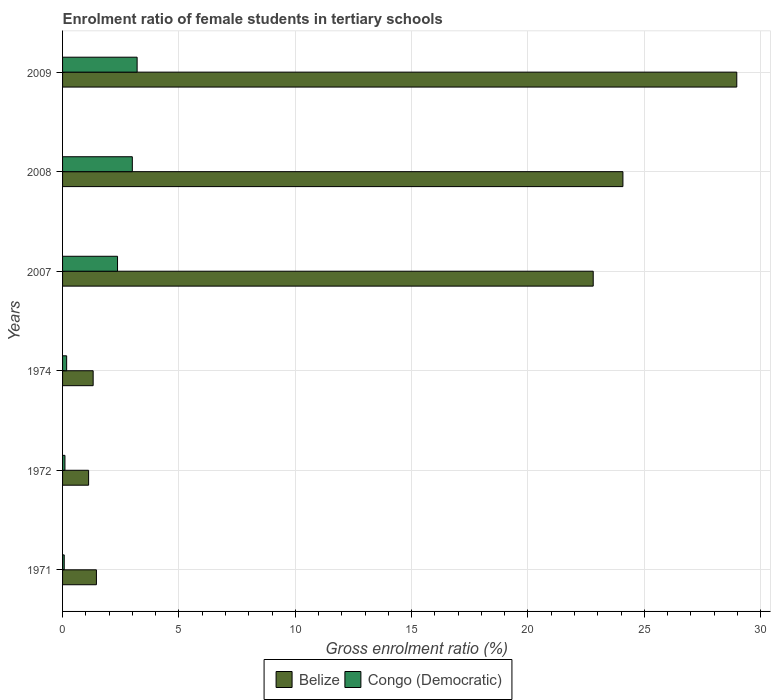Are the number of bars per tick equal to the number of legend labels?
Give a very brief answer. Yes. How many bars are there on the 1st tick from the bottom?
Your response must be concise. 2. What is the enrolment ratio of female students in tertiary schools in Belize in 2009?
Give a very brief answer. 28.97. Across all years, what is the maximum enrolment ratio of female students in tertiary schools in Congo (Democratic)?
Provide a succinct answer. 3.2. Across all years, what is the minimum enrolment ratio of female students in tertiary schools in Belize?
Provide a succinct answer. 1.12. In which year was the enrolment ratio of female students in tertiary schools in Congo (Democratic) maximum?
Your answer should be very brief. 2009. What is the total enrolment ratio of female students in tertiary schools in Congo (Democratic) in the graph?
Make the answer very short. 8.91. What is the difference between the enrolment ratio of female students in tertiary schools in Belize in 1972 and that in 1974?
Provide a succinct answer. -0.2. What is the difference between the enrolment ratio of female students in tertiary schools in Belize in 2007 and the enrolment ratio of female students in tertiary schools in Congo (Democratic) in 1972?
Provide a short and direct response. 22.7. What is the average enrolment ratio of female students in tertiary schools in Belize per year?
Provide a short and direct response. 13.29. In the year 1971, what is the difference between the enrolment ratio of female students in tertiary schools in Belize and enrolment ratio of female students in tertiary schools in Congo (Democratic)?
Ensure brevity in your answer.  1.38. In how many years, is the enrolment ratio of female students in tertiary schools in Belize greater than 29 %?
Keep it short and to the point. 0. What is the ratio of the enrolment ratio of female students in tertiary schools in Congo (Democratic) in 1972 to that in 2009?
Your response must be concise. 0.03. Is the enrolment ratio of female students in tertiary schools in Belize in 1971 less than that in 2008?
Keep it short and to the point. Yes. Is the difference between the enrolment ratio of female students in tertiary schools in Belize in 1971 and 1974 greater than the difference between the enrolment ratio of female students in tertiary schools in Congo (Democratic) in 1971 and 1974?
Offer a terse response. Yes. What is the difference between the highest and the second highest enrolment ratio of female students in tertiary schools in Belize?
Offer a terse response. 4.89. What is the difference between the highest and the lowest enrolment ratio of female students in tertiary schools in Belize?
Provide a short and direct response. 27.85. What does the 2nd bar from the top in 2007 represents?
Your answer should be very brief. Belize. What does the 2nd bar from the bottom in 1971 represents?
Your response must be concise. Congo (Democratic). How many bars are there?
Your answer should be very brief. 12. What is the difference between two consecutive major ticks on the X-axis?
Your response must be concise. 5. Does the graph contain any zero values?
Ensure brevity in your answer.  No. Does the graph contain grids?
Your response must be concise. Yes. How many legend labels are there?
Your answer should be compact. 2. What is the title of the graph?
Make the answer very short. Enrolment ratio of female students in tertiary schools. Does "Euro area" appear as one of the legend labels in the graph?
Your answer should be very brief. No. What is the label or title of the X-axis?
Offer a terse response. Gross enrolment ratio (%). What is the Gross enrolment ratio (%) of Belize in 1971?
Keep it short and to the point. 1.46. What is the Gross enrolment ratio (%) in Congo (Democratic) in 1971?
Give a very brief answer. 0.07. What is the Gross enrolment ratio (%) of Belize in 1972?
Keep it short and to the point. 1.12. What is the Gross enrolment ratio (%) in Congo (Democratic) in 1972?
Your response must be concise. 0.1. What is the Gross enrolment ratio (%) in Belize in 1974?
Your response must be concise. 1.31. What is the Gross enrolment ratio (%) in Congo (Democratic) in 1974?
Make the answer very short. 0.18. What is the Gross enrolment ratio (%) in Belize in 2007?
Offer a terse response. 22.8. What is the Gross enrolment ratio (%) of Congo (Democratic) in 2007?
Provide a succinct answer. 2.36. What is the Gross enrolment ratio (%) of Belize in 2008?
Give a very brief answer. 24.08. What is the Gross enrolment ratio (%) of Congo (Democratic) in 2008?
Make the answer very short. 3. What is the Gross enrolment ratio (%) in Belize in 2009?
Keep it short and to the point. 28.97. What is the Gross enrolment ratio (%) in Congo (Democratic) in 2009?
Offer a terse response. 3.2. Across all years, what is the maximum Gross enrolment ratio (%) of Belize?
Your response must be concise. 28.97. Across all years, what is the maximum Gross enrolment ratio (%) in Congo (Democratic)?
Ensure brevity in your answer.  3.2. Across all years, what is the minimum Gross enrolment ratio (%) in Belize?
Make the answer very short. 1.12. Across all years, what is the minimum Gross enrolment ratio (%) of Congo (Democratic)?
Your answer should be compact. 0.07. What is the total Gross enrolment ratio (%) in Belize in the graph?
Provide a succinct answer. 79.75. What is the total Gross enrolment ratio (%) in Congo (Democratic) in the graph?
Provide a short and direct response. 8.91. What is the difference between the Gross enrolment ratio (%) of Belize in 1971 and that in 1972?
Your answer should be very brief. 0.34. What is the difference between the Gross enrolment ratio (%) of Congo (Democratic) in 1971 and that in 1972?
Keep it short and to the point. -0.03. What is the difference between the Gross enrolment ratio (%) of Belize in 1971 and that in 1974?
Give a very brief answer. 0.14. What is the difference between the Gross enrolment ratio (%) of Congo (Democratic) in 1971 and that in 1974?
Provide a short and direct response. -0.1. What is the difference between the Gross enrolment ratio (%) in Belize in 1971 and that in 2007?
Offer a very short reply. -21.35. What is the difference between the Gross enrolment ratio (%) in Congo (Democratic) in 1971 and that in 2007?
Offer a very short reply. -2.29. What is the difference between the Gross enrolment ratio (%) of Belize in 1971 and that in 2008?
Your answer should be very brief. -22.63. What is the difference between the Gross enrolment ratio (%) in Congo (Democratic) in 1971 and that in 2008?
Give a very brief answer. -2.93. What is the difference between the Gross enrolment ratio (%) of Belize in 1971 and that in 2009?
Your response must be concise. -27.52. What is the difference between the Gross enrolment ratio (%) of Congo (Democratic) in 1971 and that in 2009?
Your answer should be very brief. -3.13. What is the difference between the Gross enrolment ratio (%) in Belize in 1972 and that in 1974?
Your answer should be compact. -0.2. What is the difference between the Gross enrolment ratio (%) of Congo (Democratic) in 1972 and that in 1974?
Provide a short and direct response. -0.07. What is the difference between the Gross enrolment ratio (%) in Belize in 1972 and that in 2007?
Make the answer very short. -21.68. What is the difference between the Gross enrolment ratio (%) in Congo (Democratic) in 1972 and that in 2007?
Your answer should be compact. -2.26. What is the difference between the Gross enrolment ratio (%) in Belize in 1972 and that in 2008?
Give a very brief answer. -22.96. What is the difference between the Gross enrolment ratio (%) in Congo (Democratic) in 1972 and that in 2008?
Keep it short and to the point. -2.9. What is the difference between the Gross enrolment ratio (%) of Belize in 1972 and that in 2009?
Give a very brief answer. -27.85. What is the difference between the Gross enrolment ratio (%) of Congo (Democratic) in 1972 and that in 2009?
Ensure brevity in your answer.  -3.1. What is the difference between the Gross enrolment ratio (%) of Belize in 1974 and that in 2007?
Provide a succinct answer. -21.49. What is the difference between the Gross enrolment ratio (%) in Congo (Democratic) in 1974 and that in 2007?
Give a very brief answer. -2.19. What is the difference between the Gross enrolment ratio (%) in Belize in 1974 and that in 2008?
Your answer should be very brief. -22.77. What is the difference between the Gross enrolment ratio (%) in Congo (Democratic) in 1974 and that in 2008?
Keep it short and to the point. -2.82. What is the difference between the Gross enrolment ratio (%) in Belize in 1974 and that in 2009?
Offer a terse response. -27.66. What is the difference between the Gross enrolment ratio (%) of Congo (Democratic) in 1974 and that in 2009?
Give a very brief answer. -3.03. What is the difference between the Gross enrolment ratio (%) of Belize in 2007 and that in 2008?
Provide a succinct answer. -1.28. What is the difference between the Gross enrolment ratio (%) of Congo (Democratic) in 2007 and that in 2008?
Your response must be concise. -0.64. What is the difference between the Gross enrolment ratio (%) of Belize in 2007 and that in 2009?
Provide a short and direct response. -6.17. What is the difference between the Gross enrolment ratio (%) in Congo (Democratic) in 2007 and that in 2009?
Your answer should be compact. -0.84. What is the difference between the Gross enrolment ratio (%) of Belize in 2008 and that in 2009?
Your answer should be compact. -4.89. What is the difference between the Gross enrolment ratio (%) of Congo (Democratic) in 2008 and that in 2009?
Offer a terse response. -0.21. What is the difference between the Gross enrolment ratio (%) in Belize in 1971 and the Gross enrolment ratio (%) in Congo (Democratic) in 1972?
Your response must be concise. 1.35. What is the difference between the Gross enrolment ratio (%) in Belize in 1971 and the Gross enrolment ratio (%) in Congo (Democratic) in 1974?
Make the answer very short. 1.28. What is the difference between the Gross enrolment ratio (%) in Belize in 1971 and the Gross enrolment ratio (%) in Congo (Democratic) in 2007?
Your answer should be compact. -0.91. What is the difference between the Gross enrolment ratio (%) in Belize in 1971 and the Gross enrolment ratio (%) in Congo (Democratic) in 2008?
Provide a short and direct response. -1.54. What is the difference between the Gross enrolment ratio (%) in Belize in 1971 and the Gross enrolment ratio (%) in Congo (Democratic) in 2009?
Provide a short and direct response. -1.75. What is the difference between the Gross enrolment ratio (%) of Belize in 1972 and the Gross enrolment ratio (%) of Congo (Democratic) in 1974?
Provide a short and direct response. 0.94. What is the difference between the Gross enrolment ratio (%) of Belize in 1972 and the Gross enrolment ratio (%) of Congo (Democratic) in 2007?
Provide a short and direct response. -1.24. What is the difference between the Gross enrolment ratio (%) of Belize in 1972 and the Gross enrolment ratio (%) of Congo (Democratic) in 2008?
Your answer should be compact. -1.88. What is the difference between the Gross enrolment ratio (%) in Belize in 1972 and the Gross enrolment ratio (%) in Congo (Democratic) in 2009?
Give a very brief answer. -2.08. What is the difference between the Gross enrolment ratio (%) in Belize in 1974 and the Gross enrolment ratio (%) in Congo (Democratic) in 2007?
Provide a short and direct response. -1.05. What is the difference between the Gross enrolment ratio (%) in Belize in 1974 and the Gross enrolment ratio (%) in Congo (Democratic) in 2008?
Keep it short and to the point. -1.68. What is the difference between the Gross enrolment ratio (%) in Belize in 1974 and the Gross enrolment ratio (%) in Congo (Democratic) in 2009?
Your response must be concise. -1.89. What is the difference between the Gross enrolment ratio (%) of Belize in 2007 and the Gross enrolment ratio (%) of Congo (Democratic) in 2008?
Your response must be concise. 19.81. What is the difference between the Gross enrolment ratio (%) in Belize in 2007 and the Gross enrolment ratio (%) in Congo (Democratic) in 2009?
Provide a succinct answer. 19.6. What is the difference between the Gross enrolment ratio (%) in Belize in 2008 and the Gross enrolment ratio (%) in Congo (Democratic) in 2009?
Give a very brief answer. 20.88. What is the average Gross enrolment ratio (%) of Belize per year?
Offer a terse response. 13.29. What is the average Gross enrolment ratio (%) of Congo (Democratic) per year?
Keep it short and to the point. 1.49. In the year 1971, what is the difference between the Gross enrolment ratio (%) of Belize and Gross enrolment ratio (%) of Congo (Democratic)?
Your response must be concise. 1.38. In the year 1972, what is the difference between the Gross enrolment ratio (%) of Belize and Gross enrolment ratio (%) of Congo (Democratic)?
Provide a short and direct response. 1.02. In the year 1974, what is the difference between the Gross enrolment ratio (%) of Belize and Gross enrolment ratio (%) of Congo (Democratic)?
Provide a succinct answer. 1.14. In the year 2007, what is the difference between the Gross enrolment ratio (%) in Belize and Gross enrolment ratio (%) in Congo (Democratic)?
Offer a terse response. 20.44. In the year 2008, what is the difference between the Gross enrolment ratio (%) of Belize and Gross enrolment ratio (%) of Congo (Democratic)?
Your answer should be compact. 21.08. In the year 2009, what is the difference between the Gross enrolment ratio (%) of Belize and Gross enrolment ratio (%) of Congo (Democratic)?
Provide a short and direct response. 25.77. What is the ratio of the Gross enrolment ratio (%) in Belize in 1971 to that in 1972?
Offer a terse response. 1.3. What is the ratio of the Gross enrolment ratio (%) of Congo (Democratic) in 1971 to that in 1972?
Make the answer very short. 0.7. What is the ratio of the Gross enrolment ratio (%) in Belize in 1971 to that in 1974?
Provide a succinct answer. 1.11. What is the ratio of the Gross enrolment ratio (%) of Congo (Democratic) in 1971 to that in 1974?
Provide a short and direct response. 0.41. What is the ratio of the Gross enrolment ratio (%) of Belize in 1971 to that in 2007?
Provide a succinct answer. 0.06. What is the ratio of the Gross enrolment ratio (%) of Congo (Democratic) in 1971 to that in 2007?
Ensure brevity in your answer.  0.03. What is the ratio of the Gross enrolment ratio (%) in Belize in 1971 to that in 2008?
Your answer should be very brief. 0.06. What is the ratio of the Gross enrolment ratio (%) in Congo (Democratic) in 1971 to that in 2008?
Make the answer very short. 0.02. What is the ratio of the Gross enrolment ratio (%) of Belize in 1971 to that in 2009?
Give a very brief answer. 0.05. What is the ratio of the Gross enrolment ratio (%) of Congo (Democratic) in 1971 to that in 2009?
Make the answer very short. 0.02. What is the ratio of the Gross enrolment ratio (%) of Belize in 1972 to that in 1974?
Ensure brevity in your answer.  0.85. What is the ratio of the Gross enrolment ratio (%) of Congo (Democratic) in 1972 to that in 1974?
Your response must be concise. 0.58. What is the ratio of the Gross enrolment ratio (%) of Belize in 1972 to that in 2007?
Your response must be concise. 0.05. What is the ratio of the Gross enrolment ratio (%) in Congo (Democratic) in 1972 to that in 2007?
Provide a succinct answer. 0.04. What is the ratio of the Gross enrolment ratio (%) of Belize in 1972 to that in 2008?
Your response must be concise. 0.05. What is the ratio of the Gross enrolment ratio (%) of Congo (Democratic) in 1972 to that in 2008?
Provide a short and direct response. 0.03. What is the ratio of the Gross enrolment ratio (%) in Belize in 1972 to that in 2009?
Keep it short and to the point. 0.04. What is the ratio of the Gross enrolment ratio (%) in Congo (Democratic) in 1972 to that in 2009?
Your answer should be compact. 0.03. What is the ratio of the Gross enrolment ratio (%) of Belize in 1974 to that in 2007?
Your answer should be compact. 0.06. What is the ratio of the Gross enrolment ratio (%) of Congo (Democratic) in 1974 to that in 2007?
Your answer should be very brief. 0.07. What is the ratio of the Gross enrolment ratio (%) of Belize in 1974 to that in 2008?
Give a very brief answer. 0.05. What is the ratio of the Gross enrolment ratio (%) of Congo (Democratic) in 1974 to that in 2008?
Make the answer very short. 0.06. What is the ratio of the Gross enrolment ratio (%) of Belize in 1974 to that in 2009?
Make the answer very short. 0.05. What is the ratio of the Gross enrolment ratio (%) in Congo (Democratic) in 1974 to that in 2009?
Ensure brevity in your answer.  0.05. What is the ratio of the Gross enrolment ratio (%) of Belize in 2007 to that in 2008?
Give a very brief answer. 0.95. What is the ratio of the Gross enrolment ratio (%) in Congo (Democratic) in 2007 to that in 2008?
Keep it short and to the point. 0.79. What is the ratio of the Gross enrolment ratio (%) of Belize in 2007 to that in 2009?
Make the answer very short. 0.79. What is the ratio of the Gross enrolment ratio (%) in Congo (Democratic) in 2007 to that in 2009?
Offer a very short reply. 0.74. What is the ratio of the Gross enrolment ratio (%) in Belize in 2008 to that in 2009?
Provide a succinct answer. 0.83. What is the ratio of the Gross enrolment ratio (%) of Congo (Democratic) in 2008 to that in 2009?
Make the answer very short. 0.94. What is the difference between the highest and the second highest Gross enrolment ratio (%) of Belize?
Make the answer very short. 4.89. What is the difference between the highest and the second highest Gross enrolment ratio (%) in Congo (Democratic)?
Your answer should be compact. 0.21. What is the difference between the highest and the lowest Gross enrolment ratio (%) of Belize?
Give a very brief answer. 27.85. What is the difference between the highest and the lowest Gross enrolment ratio (%) of Congo (Democratic)?
Give a very brief answer. 3.13. 